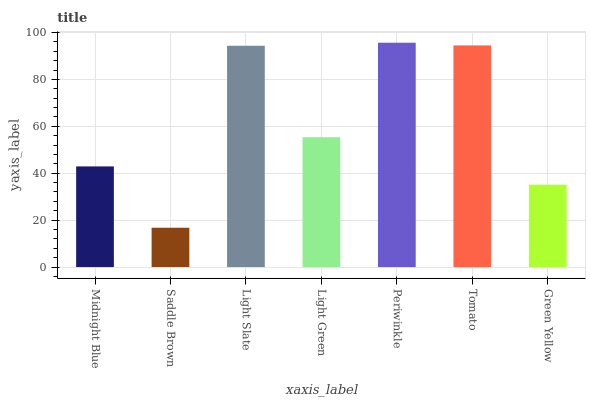Is Saddle Brown the minimum?
Answer yes or no. Yes. Is Periwinkle the maximum?
Answer yes or no. Yes. Is Light Slate the minimum?
Answer yes or no. No. Is Light Slate the maximum?
Answer yes or no. No. Is Light Slate greater than Saddle Brown?
Answer yes or no. Yes. Is Saddle Brown less than Light Slate?
Answer yes or no. Yes. Is Saddle Brown greater than Light Slate?
Answer yes or no. No. Is Light Slate less than Saddle Brown?
Answer yes or no. No. Is Light Green the high median?
Answer yes or no. Yes. Is Light Green the low median?
Answer yes or no. Yes. Is Light Slate the high median?
Answer yes or no. No. Is Green Yellow the low median?
Answer yes or no. No. 